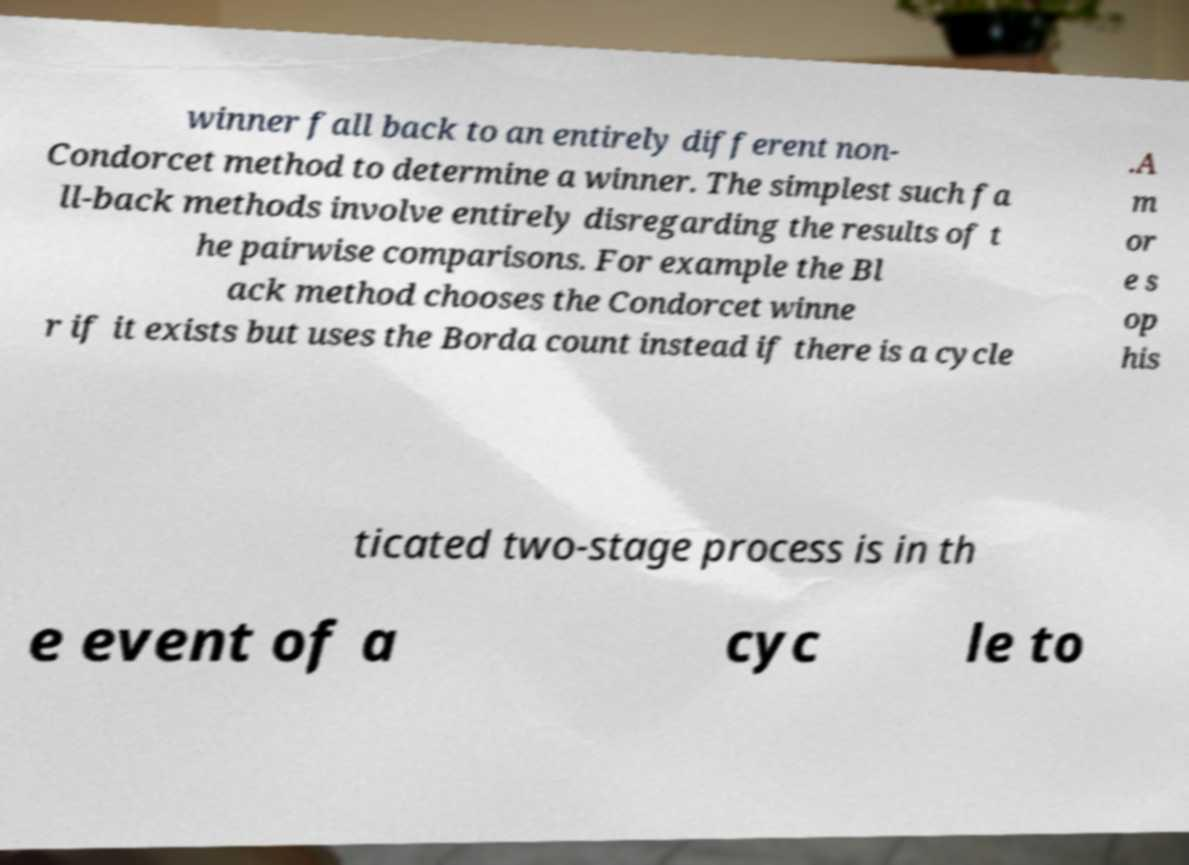Please identify and transcribe the text found in this image. winner fall back to an entirely different non- Condorcet method to determine a winner. The simplest such fa ll-back methods involve entirely disregarding the results of t he pairwise comparisons. For example the Bl ack method chooses the Condorcet winne r if it exists but uses the Borda count instead if there is a cycle .A m or e s op his ticated two-stage process is in th e event of a cyc le to 